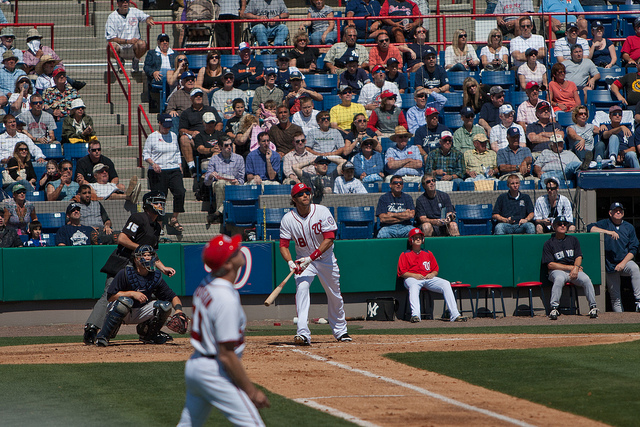Identify the text contained in this image. 15 8 